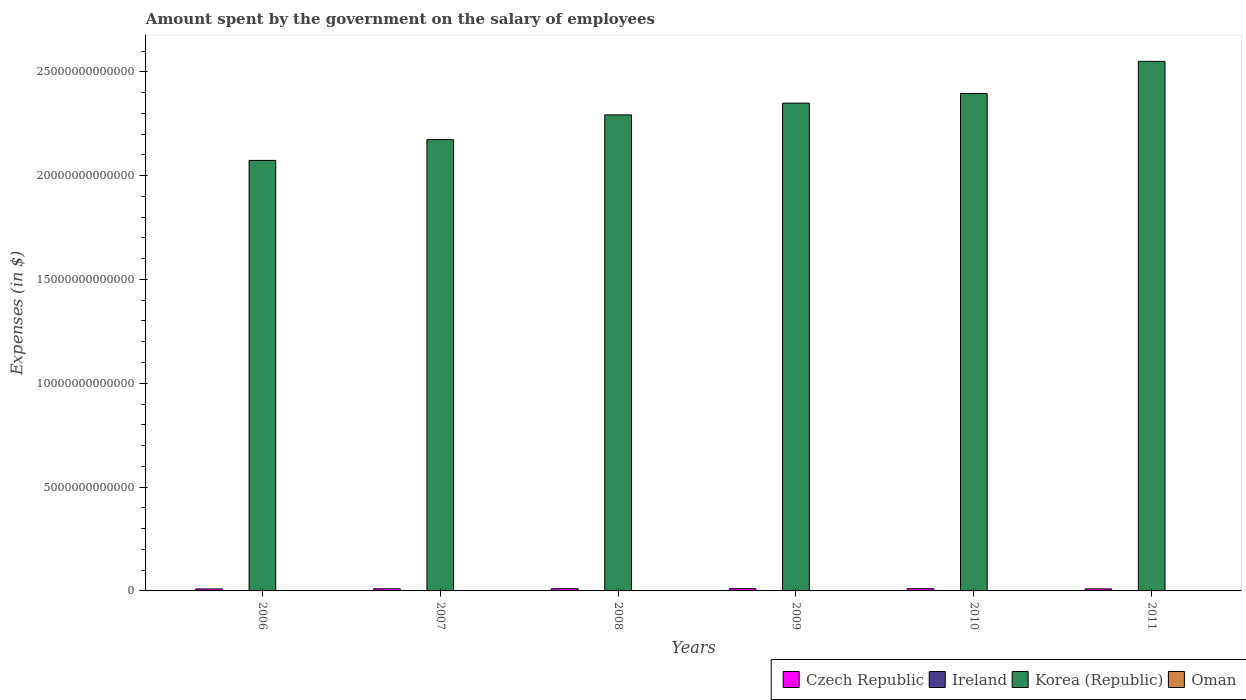How many groups of bars are there?
Your answer should be very brief. 6. How many bars are there on the 4th tick from the left?
Make the answer very short. 4. What is the label of the 6th group of bars from the left?
Ensure brevity in your answer.  2011. What is the amount spent on the salary of employees by the government in Korea (Republic) in 2007?
Your answer should be very brief. 2.17e+13. Across all years, what is the maximum amount spent on the salary of employees by the government in Oman?
Ensure brevity in your answer.  1.94e+09. Across all years, what is the minimum amount spent on the salary of employees by the government in Korea (Republic)?
Provide a succinct answer. 2.07e+13. What is the total amount spent on the salary of employees by the government in Oman in the graph?
Your response must be concise. 9.11e+09. What is the difference between the amount spent on the salary of employees by the government in Ireland in 2006 and that in 2009?
Make the answer very short. -3.15e+09. What is the difference between the amount spent on the salary of employees by the government in Oman in 2011 and the amount spent on the salary of employees by the government in Ireland in 2010?
Provide a succinct answer. -1.46e+1. What is the average amount spent on the salary of employees by the government in Ireland per year?
Your response must be concise. 1.65e+1. In the year 2006, what is the difference between the amount spent on the salary of employees by the government in Ireland and amount spent on the salary of employees by the government in Korea (Republic)?
Offer a terse response. -2.07e+13. What is the ratio of the amount spent on the salary of employees by the government in Oman in 2006 to that in 2010?
Provide a succinct answer. 0.71. What is the difference between the highest and the second highest amount spent on the salary of employees by the government in Oman?
Give a very brief answer. 2.13e+08. What is the difference between the highest and the lowest amount spent on the salary of employees by the government in Ireland?
Offer a very short reply. 3.45e+09. Is it the case that in every year, the sum of the amount spent on the salary of employees by the government in Czech Republic and amount spent on the salary of employees by the government in Korea (Republic) is greater than the sum of amount spent on the salary of employees by the government in Oman and amount spent on the salary of employees by the government in Ireland?
Your answer should be compact. No. What does the 1st bar from the left in 2007 represents?
Provide a short and direct response. Czech Republic. What does the 1st bar from the right in 2009 represents?
Ensure brevity in your answer.  Oman. How many bars are there?
Provide a short and direct response. 24. What is the difference between two consecutive major ticks on the Y-axis?
Ensure brevity in your answer.  5.00e+12. Does the graph contain any zero values?
Offer a very short reply. No. Does the graph contain grids?
Your response must be concise. No. Where does the legend appear in the graph?
Give a very brief answer. Bottom right. How many legend labels are there?
Give a very brief answer. 4. What is the title of the graph?
Your answer should be very brief. Amount spent by the government on the salary of employees. Does "Slovak Republic" appear as one of the legend labels in the graph?
Provide a succinct answer. No. What is the label or title of the Y-axis?
Offer a terse response. Expenses (in $). What is the Expenses (in $) of Czech Republic in 2006?
Your response must be concise. 9.63e+1. What is the Expenses (in $) in Ireland in 2006?
Your answer should be very brief. 1.45e+1. What is the Expenses (in $) in Korea (Republic) in 2006?
Ensure brevity in your answer.  2.07e+13. What is the Expenses (in $) of Oman in 2006?
Provide a succinct answer. 1.23e+09. What is the Expenses (in $) of Czech Republic in 2007?
Make the answer very short. 1.03e+11. What is the Expenses (in $) of Ireland in 2007?
Keep it short and to the point. 1.59e+1. What is the Expenses (in $) of Korea (Republic) in 2007?
Your answer should be compact. 2.17e+13. What is the Expenses (in $) of Oman in 2007?
Provide a short and direct response. 1.35e+09. What is the Expenses (in $) of Czech Republic in 2008?
Your answer should be very brief. 1.05e+11. What is the Expenses (in $) of Ireland in 2008?
Give a very brief answer. 1.80e+1. What is the Expenses (in $) of Korea (Republic) in 2008?
Your response must be concise. 2.29e+13. What is the Expenses (in $) in Oman in 2008?
Provide a succinct answer. 1.37e+09. What is the Expenses (in $) of Czech Republic in 2009?
Give a very brief answer. 1.09e+11. What is the Expenses (in $) in Ireland in 2009?
Provide a succinct answer. 1.77e+1. What is the Expenses (in $) of Korea (Republic) in 2009?
Keep it short and to the point. 2.35e+13. What is the Expenses (in $) of Oman in 2009?
Offer a very short reply. 1.51e+09. What is the Expenses (in $) of Czech Republic in 2010?
Provide a succinct answer. 1.06e+11. What is the Expenses (in $) of Ireland in 2010?
Provide a short and direct response. 1.65e+1. What is the Expenses (in $) of Korea (Republic) in 2010?
Offer a very short reply. 2.40e+13. What is the Expenses (in $) of Oman in 2010?
Provide a short and direct response. 1.72e+09. What is the Expenses (in $) of Czech Republic in 2011?
Keep it short and to the point. 9.72e+1. What is the Expenses (in $) in Ireland in 2011?
Give a very brief answer. 1.63e+1. What is the Expenses (in $) in Korea (Republic) in 2011?
Provide a short and direct response. 2.55e+13. What is the Expenses (in $) in Oman in 2011?
Give a very brief answer. 1.94e+09. Across all years, what is the maximum Expenses (in $) in Czech Republic?
Your response must be concise. 1.09e+11. Across all years, what is the maximum Expenses (in $) of Ireland?
Offer a terse response. 1.80e+1. Across all years, what is the maximum Expenses (in $) in Korea (Republic)?
Your answer should be very brief. 2.55e+13. Across all years, what is the maximum Expenses (in $) in Oman?
Make the answer very short. 1.94e+09. Across all years, what is the minimum Expenses (in $) in Czech Republic?
Ensure brevity in your answer.  9.63e+1. Across all years, what is the minimum Expenses (in $) of Ireland?
Provide a succinct answer. 1.45e+1. Across all years, what is the minimum Expenses (in $) of Korea (Republic)?
Provide a short and direct response. 2.07e+13. Across all years, what is the minimum Expenses (in $) in Oman?
Make the answer very short. 1.23e+09. What is the total Expenses (in $) of Czech Republic in the graph?
Provide a succinct answer. 6.16e+11. What is the total Expenses (in $) in Ireland in the graph?
Give a very brief answer. 9.89e+1. What is the total Expenses (in $) of Korea (Republic) in the graph?
Your answer should be compact. 1.38e+14. What is the total Expenses (in $) of Oman in the graph?
Give a very brief answer. 9.11e+09. What is the difference between the Expenses (in $) in Czech Republic in 2006 and that in 2007?
Make the answer very short. -6.24e+09. What is the difference between the Expenses (in $) in Ireland in 2006 and that in 2007?
Your answer should be compact. -1.43e+09. What is the difference between the Expenses (in $) in Korea (Republic) in 2006 and that in 2007?
Make the answer very short. -1.00e+12. What is the difference between the Expenses (in $) in Oman in 2006 and that in 2007?
Your answer should be very brief. -1.20e+08. What is the difference between the Expenses (in $) in Czech Republic in 2006 and that in 2008?
Offer a terse response. -9.01e+09. What is the difference between the Expenses (in $) in Ireland in 2006 and that in 2008?
Ensure brevity in your answer.  -3.45e+09. What is the difference between the Expenses (in $) of Korea (Republic) in 2006 and that in 2008?
Offer a very short reply. -2.19e+12. What is the difference between the Expenses (in $) of Oman in 2006 and that in 2008?
Offer a terse response. -1.42e+08. What is the difference between the Expenses (in $) of Czech Republic in 2006 and that in 2009?
Provide a short and direct response. -1.26e+1. What is the difference between the Expenses (in $) in Ireland in 2006 and that in 2009?
Offer a terse response. -3.15e+09. What is the difference between the Expenses (in $) of Korea (Republic) in 2006 and that in 2009?
Offer a very short reply. -2.76e+12. What is the difference between the Expenses (in $) in Oman in 2006 and that in 2009?
Your answer should be compact. -2.79e+08. What is the difference between the Expenses (in $) in Czech Republic in 2006 and that in 2010?
Make the answer very short. -9.95e+09. What is the difference between the Expenses (in $) of Ireland in 2006 and that in 2010?
Offer a very short reply. -2.00e+09. What is the difference between the Expenses (in $) of Korea (Republic) in 2006 and that in 2010?
Give a very brief answer. -3.22e+12. What is the difference between the Expenses (in $) in Oman in 2006 and that in 2010?
Provide a succinct answer. -4.95e+08. What is the difference between the Expenses (in $) in Czech Republic in 2006 and that in 2011?
Your answer should be compact. -9.25e+08. What is the difference between the Expenses (in $) in Ireland in 2006 and that in 2011?
Provide a short and direct response. -1.82e+09. What is the difference between the Expenses (in $) of Korea (Republic) in 2006 and that in 2011?
Ensure brevity in your answer.  -4.77e+12. What is the difference between the Expenses (in $) in Oman in 2006 and that in 2011?
Give a very brief answer. -7.08e+08. What is the difference between the Expenses (in $) in Czech Republic in 2007 and that in 2008?
Keep it short and to the point. -2.77e+09. What is the difference between the Expenses (in $) in Ireland in 2007 and that in 2008?
Your answer should be compact. -2.02e+09. What is the difference between the Expenses (in $) in Korea (Republic) in 2007 and that in 2008?
Provide a succinct answer. -1.19e+12. What is the difference between the Expenses (in $) in Oman in 2007 and that in 2008?
Offer a very short reply. -2.13e+07. What is the difference between the Expenses (in $) in Czech Republic in 2007 and that in 2009?
Offer a terse response. -6.33e+09. What is the difference between the Expenses (in $) of Ireland in 2007 and that in 2009?
Your answer should be compact. -1.73e+09. What is the difference between the Expenses (in $) of Korea (Republic) in 2007 and that in 2009?
Provide a succinct answer. -1.76e+12. What is the difference between the Expenses (in $) in Oman in 2007 and that in 2009?
Ensure brevity in your answer.  -1.59e+08. What is the difference between the Expenses (in $) in Czech Republic in 2007 and that in 2010?
Provide a succinct answer. -3.72e+09. What is the difference between the Expenses (in $) in Ireland in 2007 and that in 2010?
Your response must be concise. -5.68e+08. What is the difference between the Expenses (in $) in Korea (Republic) in 2007 and that in 2010?
Offer a terse response. -2.22e+12. What is the difference between the Expenses (in $) in Oman in 2007 and that in 2010?
Your response must be concise. -3.75e+08. What is the difference between the Expenses (in $) of Czech Republic in 2007 and that in 2011?
Give a very brief answer. 5.31e+09. What is the difference between the Expenses (in $) of Ireland in 2007 and that in 2011?
Provide a short and direct response. -3.91e+08. What is the difference between the Expenses (in $) of Korea (Republic) in 2007 and that in 2011?
Provide a succinct answer. -3.77e+12. What is the difference between the Expenses (in $) in Oman in 2007 and that in 2011?
Give a very brief answer. -5.88e+08. What is the difference between the Expenses (in $) in Czech Republic in 2008 and that in 2009?
Your answer should be compact. -3.56e+09. What is the difference between the Expenses (in $) of Ireland in 2008 and that in 2009?
Your response must be concise. 2.99e+08. What is the difference between the Expenses (in $) in Korea (Republic) in 2008 and that in 2009?
Provide a short and direct response. -5.65e+11. What is the difference between the Expenses (in $) in Oman in 2008 and that in 2009?
Give a very brief answer. -1.37e+08. What is the difference between the Expenses (in $) of Czech Republic in 2008 and that in 2010?
Offer a very short reply. -9.47e+08. What is the difference between the Expenses (in $) in Ireland in 2008 and that in 2010?
Your answer should be very brief. 1.46e+09. What is the difference between the Expenses (in $) in Korea (Republic) in 2008 and that in 2010?
Give a very brief answer. -1.03e+12. What is the difference between the Expenses (in $) in Oman in 2008 and that in 2010?
Your answer should be very brief. -3.54e+08. What is the difference between the Expenses (in $) in Czech Republic in 2008 and that in 2011?
Offer a terse response. 8.08e+09. What is the difference between the Expenses (in $) in Ireland in 2008 and that in 2011?
Offer a terse response. 1.63e+09. What is the difference between the Expenses (in $) of Korea (Republic) in 2008 and that in 2011?
Keep it short and to the point. -2.58e+12. What is the difference between the Expenses (in $) of Oman in 2008 and that in 2011?
Your response must be concise. -5.66e+08. What is the difference between the Expenses (in $) of Czech Republic in 2009 and that in 2010?
Offer a terse response. 2.61e+09. What is the difference between the Expenses (in $) of Ireland in 2009 and that in 2010?
Your response must be concise. 1.16e+09. What is the difference between the Expenses (in $) of Korea (Republic) in 2009 and that in 2010?
Provide a short and direct response. -4.62e+11. What is the difference between the Expenses (in $) in Oman in 2009 and that in 2010?
Keep it short and to the point. -2.16e+08. What is the difference between the Expenses (in $) in Czech Republic in 2009 and that in 2011?
Make the answer very short. 1.16e+1. What is the difference between the Expenses (in $) of Ireland in 2009 and that in 2011?
Your answer should be very brief. 1.33e+09. What is the difference between the Expenses (in $) in Korea (Republic) in 2009 and that in 2011?
Your answer should be very brief. -2.01e+12. What is the difference between the Expenses (in $) of Oman in 2009 and that in 2011?
Your response must be concise. -4.29e+08. What is the difference between the Expenses (in $) in Czech Republic in 2010 and that in 2011?
Ensure brevity in your answer.  9.03e+09. What is the difference between the Expenses (in $) of Ireland in 2010 and that in 2011?
Offer a terse response. 1.77e+08. What is the difference between the Expenses (in $) in Korea (Republic) in 2010 and that in 2011?
Your answer should be very brief. -1.55e+12. What is the difference between the Expenses (in $) in Oman in 2010 and that in 2011?
Provide a short and direct response. -2.13e+08. What is the difference between the Expenses (in $) of Czech Republic in 2006 and the Expenses (in $) of Ireland in 2007?
Offer a very short reply. 8.04e+1. What is the difference between the Expenses (in $) in Czech Republic in 2006 and the Expenses (in $) in Korea (Republic) in 2007?
Provide a succinct answer. -2.16e+13. What is the difference between the Expenses (in $) of Czech Republic in 2006 and the Expenses (in $) of Oman in 2007?
Provide a succinct answer. 9.49e+1. What is the difference between the Expenses (in $) of Ireland in 2006 and the Expenses (in $) of Korea (Republic) in 2007?
Offer a very short reply. -2.17e+13. What is the difference between the Expenses (in $) of Ireland in 2006 and the Expenses (in $) of Oman in 2007?
Ensure brevity in your answer.  1.32e+1. What is the difference between the Expenses (in $) in Korea (Republic) in 2006 and the Expenses (in $) in Oman in 2007?
Your response must be concise. 2.07e+13. What is the difference between the Expenses (in $) of Czech Republic in 2006 and the Expenses (in $) of Ireland in 2008?
Your answer should be compact. 7.83e+1. What is the difference between the Expenses (in $) in Czech Republic in 2006 and the Expenses (in $) in Korea (Republic) in 2008?
Offer a terse response. -2.28e+13. What is the difference between the Expenses (in $) of Czech Republic in 2006 and the Expenses (in $) of Oman in 2008?
Your response must be concise. 9.49e+1. What is the difference between the Expenses (in $) of Ireland in 2006 and the Expenses (in $) of Korea (Republic) in 2008?
Ensure brevity in your answer.  -2.29e+13. What is the difference between the Expenses (in $) of Ireland in 2006 and the Expenses (in $) of Oman in 2008?
Ensure brevity in your answer.  1.31e+1. What is the difference between the Expenses (in $) of Korea (Republic) in 2006 and the Expenses (in $) of Oman in 2008?
Your response must be concise. 2.07e+13. What is the difference between the Expenses (in $) of Czech Republic in 2006 and the Expenses (in $) of Ireland in 2009?
Provide a succinct answer. 7.86e+1. What is the difference between the Expenses (in $) in Czech Republic in 2006 and the Expenses (in $) in Korea (Republic) in 2009?
Your answer should be very brief. -2.34e+13. What is the difference between the Expenses (in $) in Czech Republic in 2006 and the Expenses (in $) in Oman in 2009?
Offer a terse response. 9.48e+1. What is the difference between the Expenses (in $) of Ireland in 2006 and the Expenses (in $) of Korea (Republic) in 2009?
Your answer should be very brief. -2.35e+13. What is the difference between the Expenses (in $) in Ireland in 2006 and the Expenses (in $) in Oman in 2009?
Your answer should be compact. 1.30e+1. What is the difference between the Expenses (in $) of Korea (Republic) in 2006 and the Expenses (in $) of Oman in 2009?
Your response must be concise. 2.07e+13. What is the difference between the Expenses (in $) of Czech Republic in 2006 and the Expenses (in $) of Ireland in 2010?
Make the answer very short. 7.98e+1. What is the difference between the Expenses (in $) in Czech Republic in 2006 and the Expenses (in $) in Korea (Republic) in 2010?
Offer a terse response. -2.39e+13. What is the difference between the Expenses (in $) of Czech Republic in 2006 and the Expenses (in $) of Oman in 2010?
Provide a short and direct response. 9.46e+1. What is the difference between the Expenses (in $) of Ireland in 2006 and the Expenses (in $) of Korea (Republic) in 2010?
Give a very brief answer. -2.39e+13. What is the difference between the Expenses (in $) of Ireland in 2006 and the Expenses (in $) of Oman in 2010?
Make the answer very short. 1.28e+1. What is the difference between the Expenses (in $) in Korea (Republic) in 2006 and the Expenses (in $) in Oman in 2010?
Give a very brief answer. 2.07e+13. What is the difference between the Expenses (in $) in Czech Republic in 2006 and the Expenses (in $) in Ireland in 2011?
Your answer should be very brief. 8.00e+1. What is the difference between the Expenses (in $) in Czech Republic in 2006 and the Expenses (in $) in Korea (Republic) in 2011?
Keep it short and to the point. -2.54e+13. What is the difference between the Expenses (in $) in Czech Republic in 2006 and the Expenses (in $) in Oman in 2011?
Provide a short and direct response. 9.44e+1. What is the difference between the Expenses (in $) of Ireland in 2006 and the Expenses (in $) of Korea (Republic) in 2011?
Offer a very short reply. -2.55e+13. What is the difference between the Expenses (in $) of Ireland in 2006 and the Expenses (in $) of Oman in 2011?
Offer a very short reply. 1.26e+1. What is the difference between the Expenses (in $) of Korea (Republic) in 2006 and the Expenses (in $) of Oman in 2011?
Your answer should be compact. 2.07e+13. What is the difference between the Expenses (in $) of Czech Republic in 2007 and the Expenses (in $) of Ireland in 2008?
Make the answer very short. 8.46e+1. What is the difference between the Expenses (in $) in Czech Republic in 2007 and the Expenses (in $) in Korea (Republic) in 2008?
Offer a terse response. -2.28e+13. What is the difference between the Expenses (in $) of Czech Republic in 2007 and the Expenses (in $) of Oman in 2008?
Make the answer very short. 1.01e+11. What is the difference between the Expenses (in $) in Ireland in 2007 and the Expenses (in $) in Korea (Republic) in 2008?
Your response must be concise. -2.29e+13. What is the difference between the Expenses (in $) in Ireland in 2007 and the Expenses (in $) in Oman in 2008?
Ensure brevity in your answer.  1.46e+1. What is the difference between the Expenses (in $) of Korea (Republic) in 2007 and the Expenses (in $) of Oman in 2008?
Offer a terse response. 2.17e+13. What is the difference between the Expenses (in $) of Czech Republic in 2007 and the Expenses (in $) of Ireland in 2009?
Provide a succinct answer. 8.49e+1. What is the difference between the Expenses (in $) of Czech Republic in 2007 and the Expenses (in $) of Korea (Republic) in 2009?
Provide a short and direct response. -2.34e+13. What is the difference between the Expenses (in $) in Czech Republic in 2007 and the Expenses (in $) in Oman in 2009?
Your answer should be very brief. 1.01e+11. What is the difference between the Expenses (in $) in Ireland in 2007 and the Expenses (in $) in Korea (Republic) in 2009?
Offer a very short reply. -2.35e+13. What is the difference between the Expenses (in $) in Ireland in 2007 and the Expenses (in $) in Oman in 2009?
Provide a succinct answer. 1.44e+1. What is the difference between the Expenses (in $) of Korea (Republic) in 2007 and the Expenses (in $) of Oman in 2009?
Keep it short and to the point. 2.17e+13. What is the difference between the Expenses (in $) of Czech Republic in 2007 and the Expenses (in $) of Ireland in 2010?
Your response must be concise. 8.60e+1. What is the difference between the Expenses (in $) of Czech Republic in 2007 and the Expenses (in $) of Korea (Republic) in 2010?
Make the answer very short. -2.39e+13. What is the difference between the Expenses (in $) in Czech Republic in 2007 and the Expenses (in $) in Oman in 2010?
Keep it short and to the point. 1.01e+11. What is the difference between the Expenses (in $) in Ireland in 2007 and the Expenses (in $) in Korea (Republic) in 2010?
Offer a terse response. -2.39e+13. What is the difference between the Expenses (in $) in Ireland in 2007 and the Expenses (in $) in Oman in 2010?
Your response must be concise. 1.42e+1. What is the difference between the Expenses (in $) in Korea (Republic) in 2007 and the Expenses (in $) in Oman in 2010?
Provide a succinct answer. 2.17e+13. What is the difference between the Expenses (in $) in Czech Republic in 2007 and the Expenses (in $) in Ireland in 2011?
Provide a short and direct response. 8.62e+1. What is the difference between the Expenses (in $) of Czech Republic in 2007 and the Expenses (in $) of Korea (Republic) in 2011?
Make the answer very short. -2.54e+13. What is the difference between the Expenses (in $) of Czech Republic in 2007 and the Expenses (in $) of Oman in 2011?
Keep it short and to the point. 1.01e+11. What is the difference between the Expenses (in $) of Ireland in 2007 and the Expenses (in $) of Korea (Republic) in 2011?
Give a very brief answer. -2.55e+13. What is the difference between the Expenses (in $) of Ireland in 2007 and the Expenses (in $) of Oman in 2011?
Your answer should be compact. 1.40e+1. What is the difference between the Expenses (in $) in Korea (Republic) in 2007 and the Expenses (in $) in Oman in 2011?
Your response must be concise. 2.17e+13. What is the difference between the Expenses (in $) of Czech Republic in 2008 and the Expenses (in $) of Ireland in 2009?
Offer a very short reply. 8.76e+1. What is the difference between the Expenses (in $) of Czech Republic in 2008 and the Expenses (in $) of Korea (Republic) in 2009?
Your answer should be compact. -2.34e+13. What is the difference between the Expenses (in $) in Czech Republic in 2008 and the Expenses (in $) in Oman in 2009?
Make the answer very short. 1.04e+11. What is the difference between the Expenses (in $) in Ireland in 2008 and the Expenses (in $) in Korea (Republic) in 2009?
Offer a terse response. -2.35e+13. What is the difference between the Expenses (in $) in Ireland in 2008 and the Expenses (in $) in Oman in 2009?
Offer a very short reply. 1.65e+1. What is the difference between the Expenses (in $) in Korea (Republic) in 2008 and the Expenses (in $) in Oman in 2009?
Your answer should be compact. 2.29e+13. What is the difference between the Expenses (in $) in Czech Republic in 2008 and the Expenses (in $) in Ireland in 2010?
Offer a very short reply. 8.88e+1. What is the difference between the Expenses (in $) of Czech Republic in 2008 and the Expenses (in $) of Korea (Republic) in 2010?
Provide a succinct answer. -2.38e+13. What is the difference between the Expenses (in $) of Czech Republic in 2008 and the Expenses (in $) of Oman in 2010?
Offer a terse response. 1.04e+11. What is the difference between the Expenses (in $) of Ireland in 2008 and the Expenses (in $) of Korea (Republic) in 2010?
Offer a very short reply. -2.39e+13. What is the difference between the Expenses (in $) of Ireland in 2008 and the Expenses (in $) of Oman in 2010?
Your response must be concise. 1.62e+1. What is the difference between the Expenses (in $) of Korea (Republic) in 2008 and the Expenses (in $) of Oman in 2010?
Keep it short and to the point. 2.29e+13. What is the difference between the Expenses (in $) in Czech Republic in 2008 and the Expenses (in $) in Ireland in 2011?
Ensure brevity in your answer.  8.90e+1. What is the difference between the Expenses (in $) of Czech Republic in 2008 and the Expenses (in $) of Korea (Republic) in 2011?
Ensure brevity in your answer.  -2.54e+13. What is the difference between the Expenses (in $) of Czech Republic in 2008 and the Expenses (in $) of Oman in 2011?
Your response must be concise. 1.03e+11. What is the difference between the Expenses (in $) in Ireland in 2008 and the Expenses (in $) in Korea (Republic) in 2011?
Provide a succinct answer. -2.55e+13. What is the difference between the Expenses (in $) in Ireland in 2008 and the Expenses (in $) in Oman in 2011?
Offer a very short reply. 1.60e+1. What is the difference between the Expenses (in $) in Korea (Republic) in 2008 and the Expenses (in $) in Oman in 2011?
Provide a succinct answer. 2.29e+13. What is the difference between the Expenses (in $) of Czech Republic in 2009 and the Expenses (in $) of Ireland in 2010?
Offer a terse response. 9.24e+1. What is the difference between the Expenses (in $) in Czech Republic in 2009 and the Expenses (in $) in Korea (Republic) in 2010?
Offer a very short reply. -2.38e+13. What is the difference between the Expenses (in $) in Czech Republic in 2009 and the Expenses (in $) in Oman in 2010?
Make the answer very short. 1.07e+11. What is the difference between the Expenses (in $) of Ireland in 2009 and the Expenses (in $) of Korea (Republic) in 2010?
Provide a short and direct response. -2.39e+13. What is the difference between the Expenses (in $) in Ireland in 2009 and the Expenses (in $) in Oman in 2010?
Provide a succinct answer. 1.59e+1. What is the difference between the Expenses (in $) of Korea (Republic) in 2009 and the Expenses (in $) of Oman in 2010?
Your response must be concise. 2.35e+13. What is the difference between the Expenses (in $) in Czech Republic in 2009 and the Expenses (in $) in Ireland in 2011?
Make the answer very short. 9.25e+1. What is the difference between the Expenses (in $) in Czech Republic in 2009 and the Expenses (in $) in Korea (Republic) in 2011?
Give a very brief answer. -2.54e+13. What is the difference between the Expenses (in $) in Czech Republic in 2009 and the Expenses (in $) in Oman in 2011?
Provide a short and direct response. 1.07e+11. What is the difference between the Expenses (in $) of Ireland in 2009 and the Expenses (in $) of Korea (Republic) in 2011?
Offer a very short reply. -2.55e+13. What is the difference between the Expenses (in $) in Ireland in 2009 and the Expenses (in $) in Oman in 2011?
Your answer should be very brief. 1.57e+1. What is the difference between the Expenses (in $) of Korea (Republic) in 2009 and the Expenses (in $) of Oman in 2011?
Your answer should be compact. 2.35e+13. What is the difference between the Expenses (in $) in Czech Republic in 2010 and the Expenses (in $) in Ireland in 2011?
Make the answer very short. 8.99e+1. What is the difference between the Expenses (in $) of Czech Republic in 2010 and the Expenses (in $) of Korea (Republic) in 2011?
Provide a succinct answer. -2.54e+13. What is the difference between the Expenses (in $) of Czech Republic in 2010 and the Expenses (in $) of Oman in 2011?
Give a very brief answer. 1.04e+11. What is the difference between the Expenses (in $) of Ireland in 2010 and the Expenses (in $) of Korea (Republic) in 2011?
Your response must be concise. -2.55e+13. What is the difference between the Expenses (in $) in Ireland in 2010 and the Expenses (in $) in Oman in 2011?
Make the answer very short. 1.46e+1. What is the difference between the Expenses (in $) of Korea (Republic) in 2010 and the Expenses (in $) of Oman in 2011?
Your answer should be very brief. 2.40e+13. What is the average Expenses (in $) in Czech Republic per year?
Your answer should be very brief. 1.03e+11. What is the average Expenses (in $) of Ireland per year?
Your answer should be very brief. 1.65e+1. What is the average Expenses (in $) in Korea (Republic) per year?
Your answer should be compact. 2.31e+13. What is the average Expenses (in $) of Oman per year?
Your answer should be compact. 1.52e+09. In the year 2006, what is the difference between the Expenses (in $) of Czech Republic and Expenses (in $) of Ireland?
Your answer should be compact. 8.18e+1. In the year 2006, what is the difference between the Expenses (in $) of Czech Republic and Expenses (in $) of Korea (Republic)?
Give a very brief answer. -2.06e+13. In the year 2006, what is the difference between the Expenses (in $) of Czech Republic and Expenses (in $) of Oman?
Ensure brevity in your answer.  9.51e+1. In the year 2006, what is the difference between the Expenses (in $) in Ireland and Expenses (in $) in Korea (Republic)?
Provide a succinct answer. -2.07e+13. In the year 2006, what is the difference between the Expenses (in $) in Ireland and Expenses (in $) in Oman?
Your response must be concise. 1.33e+1. In the year 2006, what is the difference between the Expenses (in $) in Korea (Republic) and Expenses (in $) in Oman?
Provide a short and direct response. 2.07e+13. In the year 2007, what is the difference between the Expenses (in $) of Czech Republic and Expenses (in $) of Ireland?
Offer a terse response. 8.66e+1. In the year 2007, what is the difference between the Expenses (in $) in Czech Republic and Expenses (in $) in Korea (Republic)?
Your answer should be compact. -2.16e+13. In the year 2007, what is the difference between the Expenses (in $) of Czech Republic and Expenses (in $) of Oman?
Ensure brevity in your answer.  1.01e+11. In the year 2007, what is the difference between the Expenses (in $) of Ireland and Expenses (in $) of Korea (Republic)?
Provide a short and direct response. -2.17e+13. In the year 2007, what is the difference between the Expenses (in $) in Ireland and Expenses (in $) in Oman?
Your answer should be very brief. 1.46e+1. In the year 2007, what is the difference between the Expenses (in $) in Korea (Republic) and Expenses (in $) in Oman?
Provide a short and direct response. 2.17e+13. In the year 2008, what is the difference between the Expenses (in $) in Czech Republic and Expenses (in $) in Ireland?
Your response must be concise. 8.73e+1. In the year 2008, what is the difference between the Expenses (in $) of Czech Republic and Expenses (in $) of Korea (Republic)?
Your answer should be very brief. -2.28e+13. In the year 2008, what is the difference between the Expenses (in $) of Czech Republic and Expenses (in $) of Oman?
Offer a terse response. 1.04e+11. In the year 2008, what is the difference between the Expenses (in $) in Ireland and Expenses (in $) in Korea (Republic)?
Ensure brevity in your answer.  -2.29e+13. In the year 2008, what is the difference between the Expenses (in $) in Ireland and Expenses (in $) in Oman?
Your answer should be compact. 1.66e+1. In the year 2008, what is the difference between the Expenses (in $) of Korea (Republic) and Expenses (in $) of Oman?
Offer a very short reply. 2.29e+13. In the year 2009, what is the difference between the Expenses (in $) in Czech Republic and Expenses (in $) in Ireland?
Offer a very short reply. 9.12e+1. In the year 2009, what is the difference between the Expenses (in $) in Czech Republic and Expenses (in $) in Korea (Republic)?
Provide a succinct answer. -2.34e+13. In the year 2009, what is the difference between the Expenses (in $) in Czech Republic and Expenses (in $) in Oman?
Provide a short and direct response. 1.07e+11. In the year 2009, what is the difference between the Expenses (in $) of Ireland and Expenses (in $) of Korea (Republic)?
Give a very brief answer. -2.35e+13. In the year 2009, what is the difference between the Expenses (in $) in Ireland and Expenses (in $) in Oman?
Offer a terse response. 1.62e+1. In the year 2009, what is the difference between the Expenses (in $) of Korea (Republic) and Expenses (in $) of Oman?
Give a very brief answer. 2.35e+13. In the year 2010, what is the difference between the Expenses (in $) of Czech Republic and Expenses (in $) of Ireland?
Provide a succinct answer. 8.97e+1. In the year 2010, what is the difference between the Expenses (in $) of Czech Republic and Expenses (in $) of Korea (Republic)?
Provide a succinct answer. -2.38e+13. In the year 2010, what is the difference between the Expenses (in $) in Czech Republic and Expenses (in $) in Oman?
Your answer should be very brief. 1.05e+11. In the year 2010, what is the difference between the Expenses (in $) of Ireland and Expenses (in $) of Korea (Republic)?
Offer a terse response. -2.39e+13. In the year 2010, what is the difference between the Expenses (in $) of Ireland and Expenses (in $) of Oman?
Keep it short and to the point. 1.48e+1. In the year 2010, what is the difference between the Expenses (in $) in Korea (Republic) and Expenses (in $) in Oman?
Offer a terse response. 2.40e+13. In the year 2011, what is the difference between the Expenses (in $) of Czech Republic and Expenses (in $) of Ireland?
Your answer should be compact. 8.09e+1. In the year 2011, what is the difference between the Expenses (in $) in Czech Republic and Expenses (in $) in Korea (Republic)?
Keep it short and to the point. -2.54e+13. In the year 2011, what is the difference between the Expenses (in $) in Czech Republic and Expenses (in $) in Oman?
Your response must be concise. 9.53e+1. In the year 2011, what is the difference between the Expenses (in $) in Ireland and Expenses (in $) in Korea (Republic)?
Your answer should be compact. -2.55e+13. In the year 2011, what is the difference between the Expenses (in $) in Ireland and Expenses (in $) in Oman?
Your response must be concise. 1.44e+1. In the year 2011, what is the difference between the Expenses (in $) in Korea (Republic) and Expenses (in $) in Oman?
Provide a short and direct response. 2.55e+13. What is the ratio of the Expenses (in $) of Czech Republic in 2006 to that in 2007?
Give a very brief answer. 0.94. What is the ratio of the Expenses (in $) of Ireland in 2006 to that in 2007?
Make the answer very short. 0.91. What is the ratio of the Expenses (in $) in Korea (Republic) in 2006 to that in 2007?
Keep it short and to the point. 0.95. What is the ratio of the Expenses (in $) of Oman in 2006 to that in 2007?
Offer a very short reply. 0.91. What is the ratio of the Expenses (in $) of Czech Republic in 2006 to that in 2008?
Offer a very short reply. 0.91. What is the ratio of the Expenses (in $) of Ireland in 2006 to that in 2008?
Offer a terse response. 0.81. What is the ratio of the Expenses (in $) in Korea (Republic) in 2006 to that in 2008?
Make the answer very short. 0.9. What is the ratio of the Expenses (in $) of Oman in 2006 to that in 2008?
Your answer should be very brief. 0.9. What is the ratio of the Expenses (in $) in Czech Republic in 2006 to that in 2009?
Your response must be concise. 0.88. What is the ratio of the Expenses (in $) of Ireland in 2006 to that in 2009?
Your response must be concise. 0.82. What is the ratio of the Expenses (in $) of Korea (Republic) in 2006 to that in 2009?
Your response must be concise. 0.88. What is the ratio of the Expenses (in $) in Oman in 2006 to that in 2009?
Give a very brief answer. 0.81. What is the ratio of the Expenses (in $) in Czech Republic in 2006 to that in 2010?
Provide a short and direct response. 0.91. What is the ratio of the Expenses (in $) of Ireland in 2006 to that in 2010?
Ensure brevity in your answer.  0.88. What is the ratio of the Expenses (in $) of Korea (Republic) in 2006 to that in 2010?
Ensure brevity in your answer.  0.87. What is the ratio of the Expenses (in $) of Oman in 2006 to that in 2010?
Keep it short and to the point. 0.71. What is the ratio of the Expenses (in $) in Czech Republic in 2006 to that in 2011?
Ensure brevity in your answer.  0.99. What is the ratio of the Expenses (in $) of Ireland in 2006 to that in 2011?
Your answer should be compact. 0.89. What is the ratio of the Expenses (in $) in Korea (Republic) in 2006 to that in 2011?
Provide a short and direct response. 0.81. What is the ratio of the Expenses (in $) of Oman in 2006 to that in 2011?
Keep it short and to the point. 0.63. What is the ratio of the Expenses (in $) of Czech Republic in 2007 to that in 2008?
Give a very brief answer. 0.97. What is the ratio of the Expenses (in $) of Ireland in 2007 to that in 2008?
Make the answer very short. 0.89. What is the ratio of the Expenses (in $) in Korea (Republic) in 2007 to that in 2008?
Your response must be concise. 0.95. What is the ratio of the Expenses (in $) in Oman in 2007 to that in 2008?
Give a very brief answer. 0.98. What is the ratio of the Expenses (in $) of Czech Republic in 2007 to that in 2009?
Your answer should be very brief. 0.94. What is the ratio of the Expenses (in $) of Ireland in 2007 to that in 2009?
Make the answer very short. 0.9. What is the ratio of the Expenses (in $) of Korea (Republic) in 2007 to that in 2009?
Give a very brief answer. 0.93. What is the ratio of the Expenses (in $) of Oman in 2007 to that in 2009?
Your answer should be very brief. 0.89. What is the ratio of the Expenses (in $) in Czech Republic in 2007 to that in 2010?
Your answer should be very brief. 0.96. What is the ratio of the Expenses (in $) in Ireland in 2007 to that in 2010?
Provide a succinct answer. 0.97. What is the ratio of the Expenses (in $) of Korea (Republic) in 2007 to that in 2010?
Provide a succinct answer. 0.91. What is the ratio of the Expenses (in $) in Oman in 2007 to that in 2010?
Offer a terse response. 0.78. What is the ratio of the Expenses (in $) of Czech Republic in 2007 to that in 2011?
Provide a succinct answer. 1.05. What is the ratio of the Expenses (in $) in Korea (Republic) in 2007 to that in 2011?
Provide a succinct answer. 0.85. What is the ratio of the Expenses (in $) in Oman in 2007 to that in 2011?
Your answer should be very brief. 0.7. What is the ratio of the Expenses (in $) of Czech Republic in 2008 to that in 2009?
Your answer should be compact. 0.97. What is the ratio of the Expenses (in $) in Ireland in 2008 to that in 2009?
Your answer should be very brief. 1.02. What is the ratio of the Expenses (in $) of Korea (Republic) in 2008 to that in 2009?
Provide a short and direct response. 0.98. What is the ratio of the Expenses (in $) in Oman in 2008 to that in 2009?
Your answer should be very brief. 0.91. What is the ratio of the Expenses (in $) of Czech Republic in 2008 to that in 2010?
Keep it short and to the point. 0.99. What is the ratio of the Expenses (in $) of Ireland in 2008 to that in 2010?
Provide a succinct answer. 1.09. What is the ratio of the Expenses (in $) of Korea (Republic) in 2008 to that in 2010?
Offer a terse response. 0.96. What is the ratio of the Expenses (in $) in Oman in 2008 to that in 2010?
Provide a succinct answer. 0.79. What is the ratio of the Expenses (in $) in Czech Republic in 2008 to that in 2011?
Offer a very short reply. 1.08. What is the ratio of the Expenses (in $) in Korea (Republic) in 2008 to that in 2011?
Your answer should be very brief. 0.9. What is the ratio of the Expenses (in $) of Oman in 2008 to that in 2011?
Make the answer very short. 0.71. What is the ratio of the Expenses (in $) in Czech Republic in 2009 to that in 2010?
Your answer should be very brief. 1.02. What is the ratio of the Expenses (in $) of Ireland in 2009 to that in 2010?
Give a very brief answer. 1.07. What is the ratio of the Expenses (in $) of Korea (Republic) in 2009 to that in 2010?
Your answer should be very brief. 0.98. What is the ratio of the Expenses (in $) in Oman in 2009 to that in 2010?
Your answer should be compact. 0.87. What is the ratio of the Expenses (in $) in Czech Republic in 2009 to that in 2011?
Provide a short and direct response. 1.12. What is the ratio of the Expenses (in $) of Ireland in 2009 to that in 2011?
Offer a terse response. 1.08. What is the ratio of the Expenses (in $) in Korea (Republic) in 2009 to that in 2011?
Your response must be concise. 0.92. What is the ratio of the Expenses (in $) of Oman in 2009 to that in 2011?
Your answer should be very brief. 0.78. What is the ratio of the Expenses (in $) in Czech Republic in 2010 to that in 2011?
Give a very brief answer. 1.09. What is the ratio of the Expenses (in $) in Ireland in 2010 to that in 2011?
Offer a very short reply. 1.01. What is the ratio of the Expenses (in $) of Korea (Republic) in 2010 to that in 2011?
Your response must be concise. 0.94. What is the ratio of the Expenses (in $) of Oman in 2010 to that in 2011?
Provide a succinct answer. 0.89. What is the difference between the highest and the second highest Expenses (in $) in Czech Republic?
Give a very brief answer. 2.61e+09. What is the difference between the highest and the second highest Expenses (in $) in Ireland?
Your response must be concise. 2.99e+08. What is the difference between the highest and the second highest Expenses (in $) in Korea (Republic)?
Provide a short and direct response. 1.55e+12. What is the difference between the highest and the second highest Expenses (in $) in Oman?
Your response must be concise. 2.13e+08. What is the difference between the highest and the lowest Expenses (in $) in Czech Republic?
Make the answer very short. 1.26e+1. What is the difference between the highest and the lowest Expenses (in $) in Ireland?
Offer a very short reply. 3.45e+09. What is the difference between the highest and the lowest Expenses (in $) in Korea (Republic)?
Your answer should be very brief. 4.77e+12. What is the difference between the highest and the lowest Expenses (in $) of Oman?
Provide a short and direct response. 7.08e+08. 